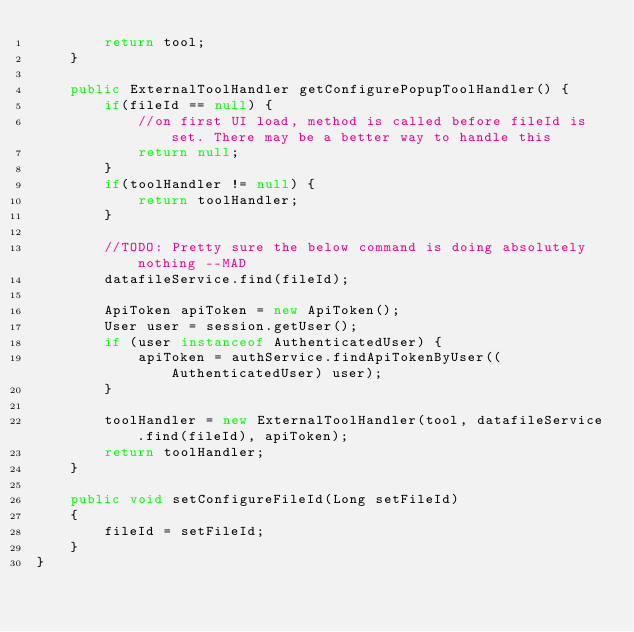<code> <loc_0><loc_0><loc_500><loc_500><_Java_>        return tool;
    }
    
    public ExternalToolHandler getConfigurePopupToolHandler() {
        if(fileId == null) {
            //on first UI load, method is called before fileId is set. There may be a better way to handle this
            return null;
        }
        if(toolHandler != null) {
            return toolHandler;
        }
        
        //TODO: Pretty sure the below command is doing absolutely nothing --MAD
        datafileService.find(fileId);
        
        ApiToken apiToken = new ApiToken();
        User user = session.getUser();
        if (user instanceof AuthenticatedUser) {
            apiToken = authService.findApiTokenByUser((AuthenticatedUser) user);
        }
        
        toolHandler = new ExternalToolHandler(tool, datafileService.find(fileId), apiToken);
        return toolHandler;
    }
    
    public void setConfigureFileId(Long setFileId)
    {
        fileId = setFileId;
    }
}
</code> 